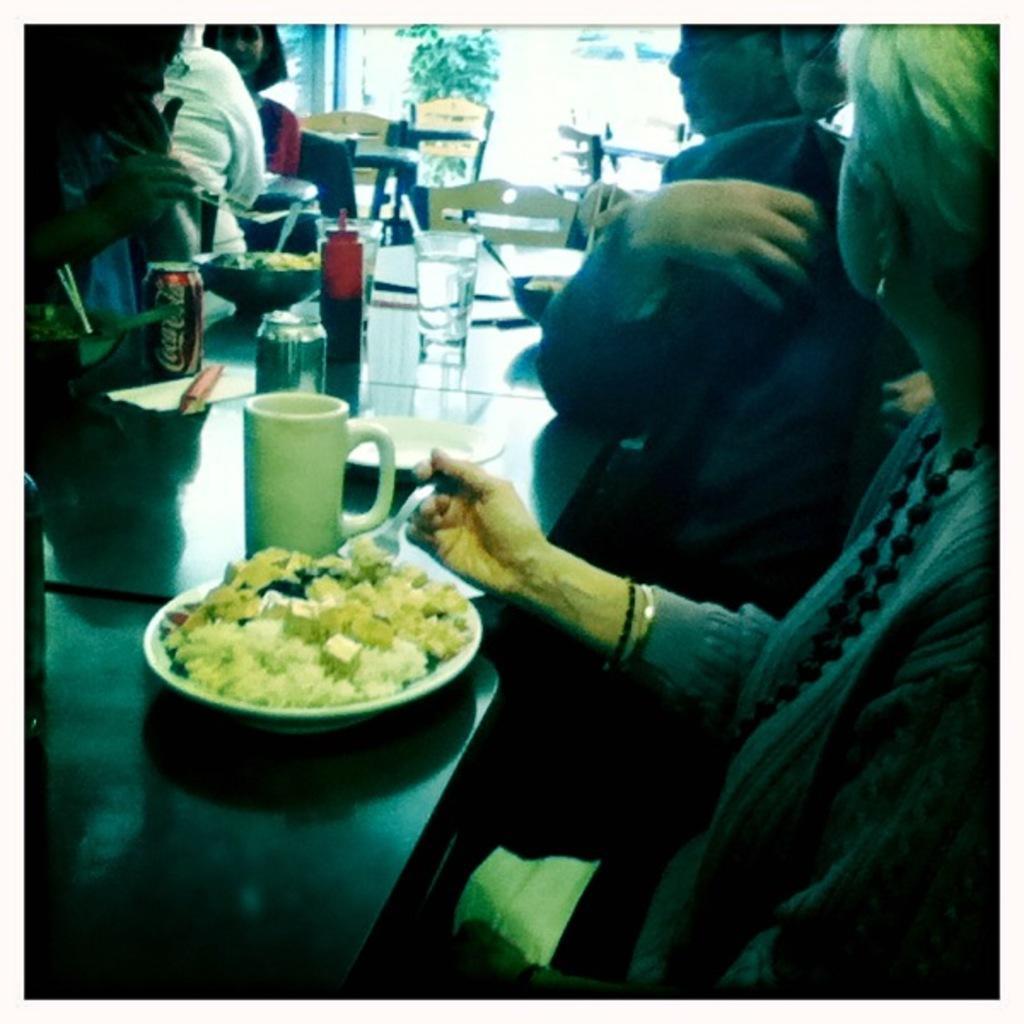Can you describe this image briefly? In this image I see few people who are sitting on chairs and I see tables over here on which there are glasses, a can, a bottle, a cup and I see plate over here on which there is food and I see 2 bowls and I see that this woman is holding a fork in her hand. In the background I see the chairs and I see the leaves over here. 